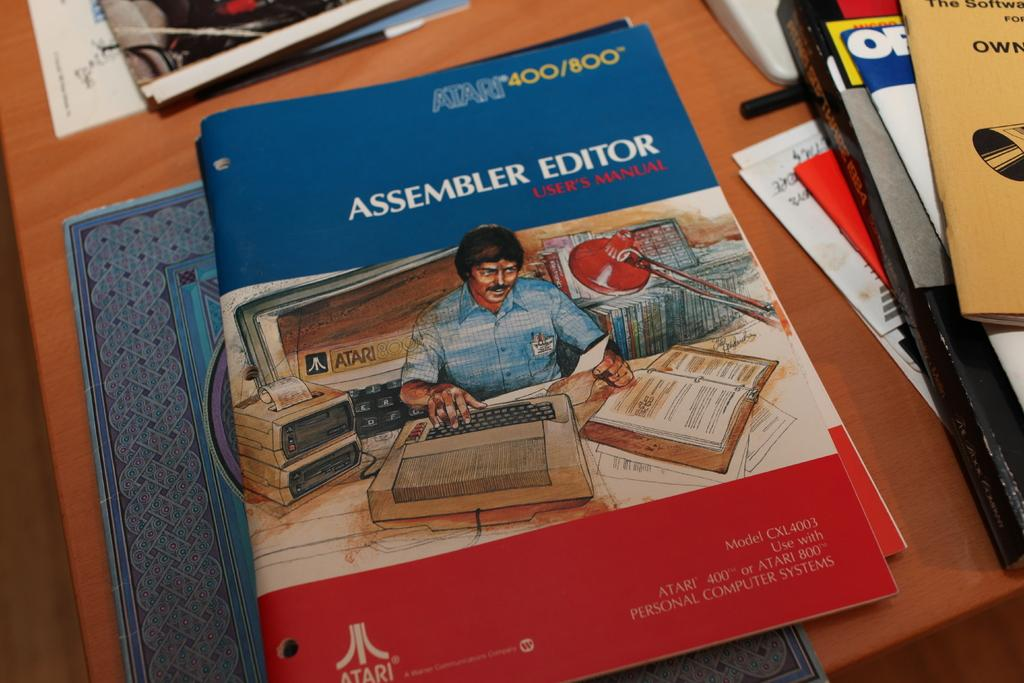<image>
Give a short and clear explanation of the subsequent image. An Assembler Editor book has a man in a blue shirt on the cover. 